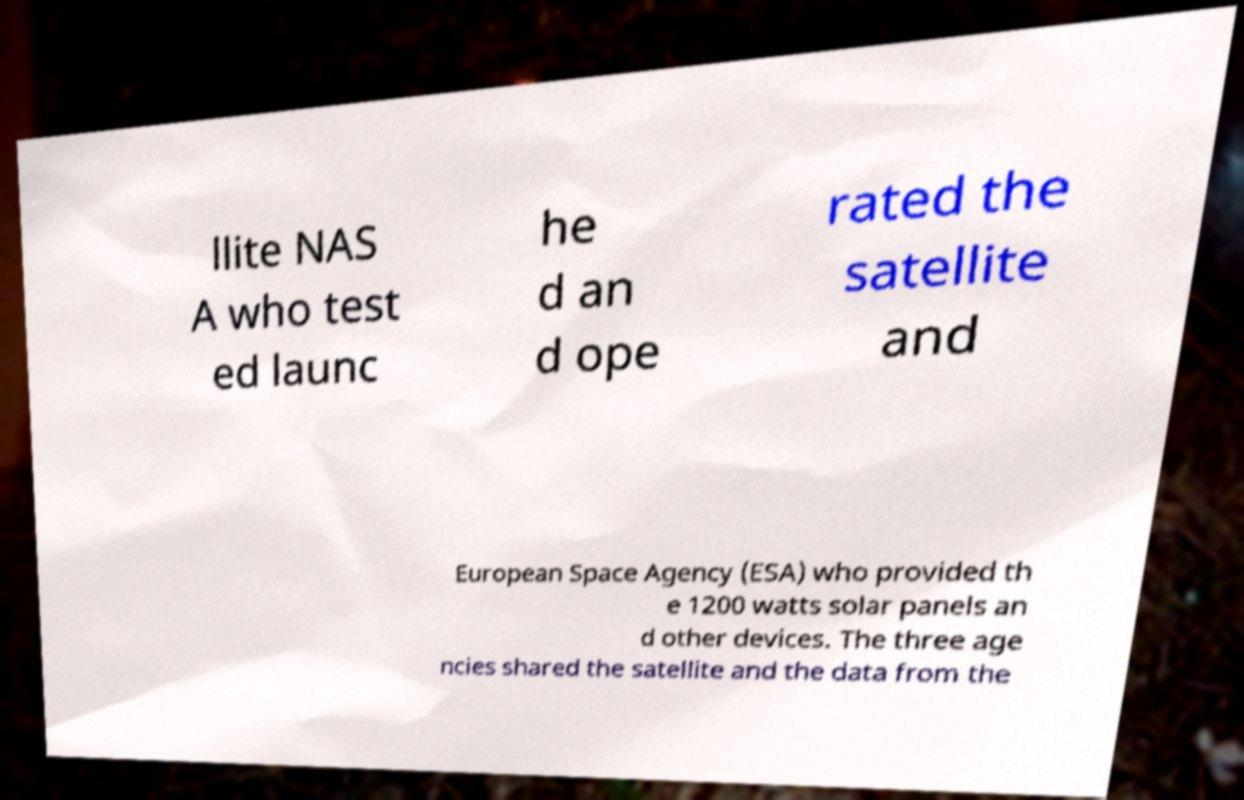Could you assist in decoding the text presented in this image and type it out clearly? llite NAS A who test ed launc he d an d ope rated the satellite and European Space Agency (ESA) who provided th e 1200 watts solar panels an d other devices. The three age ncies shared the satellite and the data from the 